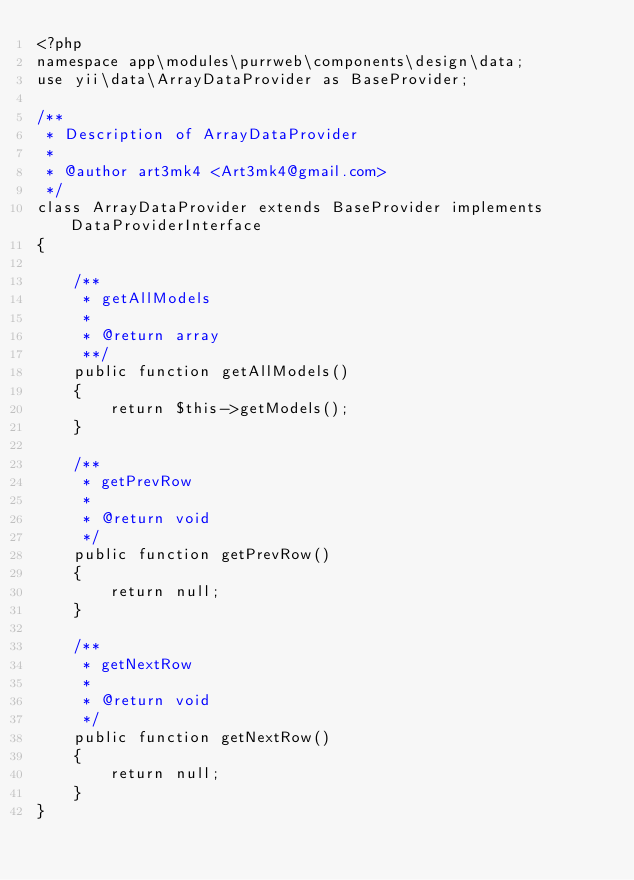<code> <loc_0><loc_0><loc_500><loc_500><_PHP_><?php
namespace app\modules\purrweb\components\design\data;
use yii\data\ArrayDataProvider as BaseProvider;

/**
 * Description of ArrayDataProvider
 *
 * @author art3mk4 <Art3mk4@gmail.com>
 */
class ArrayDataProvider extends BaseProvider implements DataProviderInterface
{

    /**
     * getAllModels
     *
     * @return array
     **/
    public function getAllModels()
    {
        return $this->getModels();
    }

    /**
     * getPrevRow
     *
     * @return void
     */
    public function getPrevRow()
    {
        return null;
    }

    /**
     * getNextRow
     *
     * @return void
     */
    public function getNextRow()
    {
        return null;
    }
}</code> 